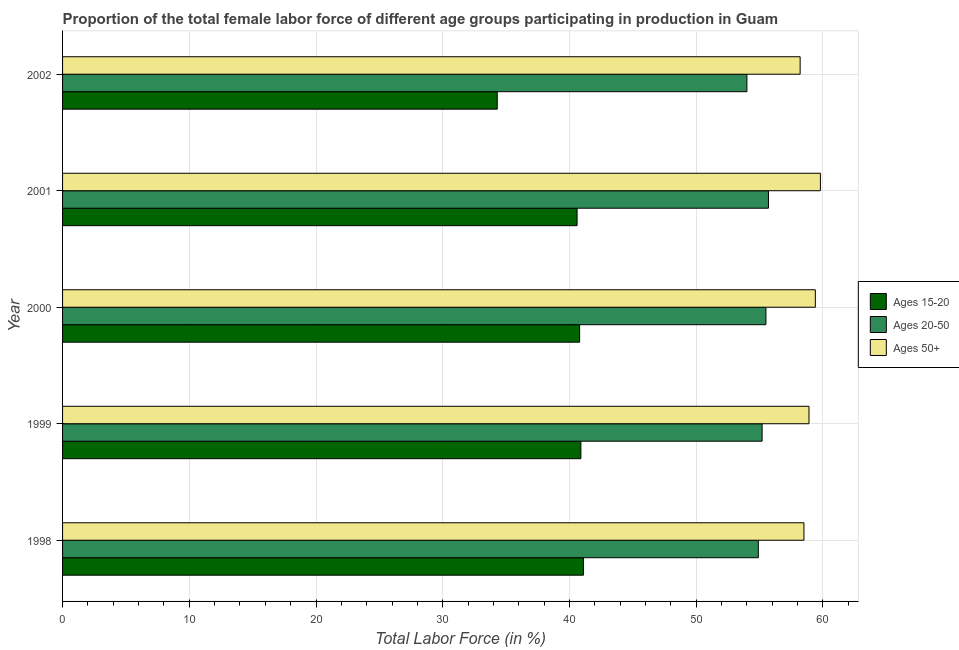How many different coloured bars are there?
Give a very brief answer. 3. Are the number of bars per tick equal to the number of legend labels?
Your answer should be compact. Yes. How many bars are there on the 3rd tick from the bottom?
Give a very brief answer. 3. What is the label of the 3rd group of bars from the top?
Offer a very short reply. 2000. In how many cases, is the number of bars for a given year not equal to the number of legend labels?
Offer a very short reply. 0. What is the percentage of female labor force above age 50 in 1998?
Provide a succinct answer. 58.5. Across all years, what is the maximum percentage of female labor force within the age group 15-20?
Keep it short and to the point. 41.1. In which year was the percentage of female labor force within the age group 20-50 maximum?
Give a very brief answer. 2001. What is the total percentage of female labor force within the age group 15-20 in the graph?
Your answer should be very brief. 197.7. What is the difference between the percentage of female labor force above age 50 in 2001 and that in 2002?
Offer a very short reply. 1.6. What is the difference between the percentage of female labor force within the age group 15-20 in 1998 and the percentage of female labor force above age 50 in 1999?
Keep it short and to the point. -17.8. What is the average percentage of female labor force within the age group 20-50 per year?
Offer a very short reply. 55.06. In how many years, is the percentage of female labor force within the age group 20-50 greater than 18 %?
Your answer should be very brief. 5. What is the ratio of the percentage of female labor force above age 50 in 1999 to that in 2002?
Ensure brevity in your answer.  1.01. Is the difference between the percentage of female labor force within the age group 20-50 in 1998 and 1999 greater than the difference between the percentage of female labor force within the age group 15-20 in 1998 and 1999?
Make the answer very short. No. What does the 3rd bar from the top in 2002 represents?
Offer a terse response. Ages 15-20. What does the 3rd bar from the bottom in 1999 represents?
Keep it short and to the point. Ages 50+. How many bars are there?
Provide a succinct answer. 15. Are all the bars in the graph horizontal?
Provide a short and direct response. Yes. How many years are there in the graph?
Provide a succinct answer. 5. Are the values on the major ticks of X-axis written in scientific E-notation?
Your response must be concise. No. What is the title of the graph?
Provide a short and direct response. Proportion of the total female labor force of different age groups participating in production in Guam. What is the Total Labor Force (in %) in Ages 15-20 in 1998?
Give a very brief answer. 41.1. What is the Total Labor Force (in %) of Ages 20-50 in 1998?
Your answer should be compact. 54.9. What is the Total Labor Force (in %) in Ages 50+ in 1998?
Provide a short and direct response. 58.5. What is the Total Labor Force (in %) of Ages 15-20 in 1999?
Provide a short and direct response. 40.9. What is the Total Labor Force (in %) in Ages 20-50 in 1999?
Make the answer very short. 55.2. What is the Total Labor Force (in %) of Ages 50+ in 1999?
Keep it short and to the point. 58.9. What is the Total Labor Force (in %) in Ages 15-20 in 2000?
Provide a short and direct response. 40.8. What is the Total Labor Force (in %) in Ages 20-50 in 2000?
Ensure brevity in your answer.  55.5. What is the Total Labor Force (in %) of Ages 50+ in 2000?
Give a very brief answer. 59.4. What is the Total Labor Force (in %) of Ages 15-20 in 2001?
Provide a succinct answer. 40.6. What is the Total Labor Force (in %) of Ages 20-50 in 2001?
Your response must be concise. 55.7. What is the Total Labor Force (in %) in Ages 50+ in 2001?
Make the answer very short. 59.8. What is the Total Labor Force (in %) in Ages 15-20 in 2002?
Offer a terse response. 34.3. What is the Total Labor Force (in %) of Ages 20-50 in 2002?
Provide a short and direct response. 54. What is the Total Labor Force (in %) of Ages 50+ in 2002?
Ensure brevity in your answer.  58.2. Across all years, what is the maximum Total Labor Force (in %) of Ages 15-20?
Give a very brief answer. 41.1. Across all years, what is the maximum Total Labor Force (in %) in Ages 20-50?
Offer a terse response. 55.7. Across all years, what is the maximum Total Labor Force (in %) in Ages 50+?
Make the answer very short. 59.8. Across all years, what is the minimum Total Labor Force (in %) of Ages 15-20?
Your response must be concise. 34.3. Across all years, what is the minimum Total Labor Force (in %) in Ages 50+?
Your answer should be compact. 58.2. What is the total Total Labor Force (in %) in Ages 15-20 in the graph?
Ensure brevity in your answer.  197.7. What is the total Total Labor Force (in %) of Ages 20-50 in the graph?
Offer a terse response. 275.3. What is the total Total Labor Force (in %) of Ages 50+ in the graph?
Your answer should be compact. 294.8. What is the difference between the Total Labor Force (in %) in Ages 15-20 in 1998 and that in 1999?
Give a very brief answer. 0.2. What is the difference between the Total Labor Force (in %) in Ages 20-50 in 1998 and that in 1999?
Make the answer very short. -0.3. What is the difference between the Total Labor Force (in %) of Ages 15-20 in 1998 and that in 2002?
Make the answer very short. 6.8. What is the difference between the Total Labor Force (in %) of Ages 50+ in 1998 and that in 2002?
Your answer should be compact. 0.3. What is the difference between the Total Labor Force (in %) in Ages 15-20 in 1999 and that in 2000?
Offer a very short reply. 0.1. What is the difference between the Total Labor Force (in %) of Ages 50+ in 1999 and that in 2000?
Offer a very short reply. -0.5. What is the difference between the Total Labor Force (in %) in Ages 15-20 in 1999 and that in 2001?
Give a very brief answer. 0.3. What is the difference between the Total Labor Force (in %) of Ages 20-50 in 1999 and that in 2001?
Make the answer very short. -0.5. What is the difference between the Total Labor Force (in %) of Ages 15-20 in 1999 and that in 2002?
Offer a very short reply. 6.6. What is the difference between the Total Labor Force (in %) of Ages 20-50 in 1999 and that in 2002?
Your answer should be very brief. 1.2. What is the difference between the Total Labor Force (in %) in Ages 15-20 in 2000 and that in 2001?
Keep it short and to the point. 0.2. What is the difference between the Total Labor Force (in %) in Ages 15-20 in 2001 and that in 2002?
Provide a short and direct response. 6.3. What is the difference between the Total Labor Force (in %) of Ages 50+ in 2001 and that in 2002?
Your answer should be very brief. 1.6. What is the difference between the Total Labor Force (in %) in Ages 15-20 in 1998 and the Total Labor Force (in %) in Ages 20-50 in 1999?
Provide a succinct answer. -14.1. What is the difference between the Total Labor Force (in %) in Ages 15-20 in 1998 and the Total Labor Force (in %) in Ages 50+ in 1999?
Your answer should be compact. -17.8. What is the difference between the Total Labor Force (in %) of Ages 15-20 in 1998 and the Total Labor Force (in %) of Ages 20-50 in 2000?
Offer a terse response. -14.4. What is the difference between the Total Labor Force (in %) in Ages 15-20 in 1998 and the Total Labor Force (in %) in Ages 50+ in 2000?
Offer a very short reply. -18.3. What is the difference between the Total Labor Force (in %) of Ages 20-50 in 1998 and the Total Labor Force (in %) of Ages 50+ in 2000?
Provide a short and direct response. -4.5. What is the difference between the Total Labor Force (in %) of Ages 15-20 in 1998 and the Total Labor Force (in %) of Ages 20-50 in 2001?
Your response must be concise. -14.6. What is the difference between the Total Labor Force (in %) in Ages 15-20 in 1998 and the Total Labor Force (in %) in Ages 50+ in 2001?
Offer a terse response. -18.7. What is the difference between the Total Labor Force (in %) in Ages 20-50 in 1998 and the Total Labor Force (in %) in Ages 50+ in 2001?
Your answer should be compact. -4.9. What is the difference between the Total Labor Force (in %) in Ages 15-20 in 1998 and the Total Labor Force (in %) in Ages 20-50 in 2002?
Make the answer very short. -12.9. What is the difference between the Total Labor Force (in %) of Ages 15-20 in 1998 and the Total Labor Force (in %) of Ages 50+ in 2002?
Offer a terse response. -17.1. What is the difference between the Total Labor Force (in %) in Ages 20-50 in 1998 and the Total Labor Force (in %) in Ages 50+ in 2002?
Offer a very short reply. -3.3. What is the difference between the Total Labor Force (in %) in Ages 15-20 in 1999 and the Total Labor Force (in %) in Ages 20-50 in 2000?
Keep it short and to the point. -14.6. What is the difference between the Total Labor Force (in %) in Ages 15-20 in 1999 and the Total Labor Force (in %) in Ages 50+ in 2000?
Give a very brief answer. -18.5. What is the difference between the Total Labor Force (in %) in Ages 20-50 in 1999 and the Total Labor Force (in %) in Ages 50+ in 2000?
Your answer should be compact. -4.2. What is the difference between the Total Labor Force (in %) of Ages 15-20 in 1999 and the Total Labor Force (in %) of Ages 20-50 in 2001?
Offer a terse response. -14.8. What is the difference between the Total Labor Force (in %) of Ages 15-20 in 1999 and the Total Labor Force (in %) of Ages 50+ in 2001?
Your answer should be compact. -18.9. What is the difference between the Total Labor Force (in %) of Ages 20-50 in 1999 and the Total Labor Force (in %) of Ages 50+ in 2001?
Your answer should be compact. -4.6. What is the difference between the Total Labor Force (in %) in Ages 15-20 in 1999 and the Total Labor Force (in %) in Ages 20-50 in 2002?
Your answer should be very brief. -13.1. What is the difference between the Total Labor Force (in %) of Ages 15-20 in 1999 and the Total Labor Force (in %) of Ages 50+ in 2002?
Your answer should be compact. -17.3. What is the difference between the Total Labor Force (in %) in Ages 20-50 in 1999 and the Total Labor Force (in %) in Ages 50+ in 2002?
Your answer should be compact. -3. What is the difference between the Total Labor Force (in %) of Ages 15-20 in 2000 and the Total Labor Force (in %) of Ages 20-50 in 2001?
Keep it short and to the point. -14.9. What is the difference between the Total Labor Force (in %) in Ages 15-20 in 2000 and the Total Labor Force (in %) in Ages 50+ in 2001?
Ensure brevity in your answer.  -19. What is the difference between the Total Labor Force (in %) of Ages 15-20 in 2000 and the Total Labor Force (in %) of Ages 20-50 in 2002?
Your response must be concise. -13.2. What is the difference between the Total Labor Force (in %) of Ages 15-20 in 2000 and the Total Labor Force (in %) of Ages 50+ in 2002?
Give a very brief answer. -17.4. What is the difference between the Total Labor Force (in %) of Ages 20-50 in 2000 and the Total Labor Force (in %) of Ages 50+ in 2002?
Make the answer very short. -2.7. What is the difference between the Total Labor Force (in %) of Ages 15-20 in 2001 and the Total Labor Force (in %) of Ages 50+ in 2002?
Offer a terse response. -17.6. What is the average Total Labor Force (in %) of Ages 15-20 per year?
Provide a short and direct response. 39.54. What is the average Total Labor Force (in %) of Ages 20-50 per year?
Keep it short and to the point. 55.06. What is the average Total Labor Force (in %) of Ages 50+ per year?
Offer a very short reply. 58.96. In the year 1998, what is the difference between the Total Labor Force (in %) in Ages 15-20 and Total Labor Force (in %) in Ages 50+?
Keep it short and to the point. -17.4. In the year 1998, what is the difference between the Total Labor Force (in %) of Ages 20-50 and Total Labor Force (in %) of Ages 50+?
Your answer should be very brief. -3.6. In the year 1999, what is the difference between the Total Labor Force (in %) of Ages 15-20 and Total Labor Force (in %) of Ages 20-50?
Keep it short and to the point. -14.3. In the year 2000, what is the difference between the Total Labor Force (in %) in Ages 15-20 and Total Labor Force (in %) in Ages 20-50?
Give a very brief answer. -14.7. In the year 2000, what is the difference between the Total Labor Force (in %) of Ages 15-20 and Total Labor Force (in %) of Ages 50+?
Your answer should be compact. -18.6. In the year 2001, what is the difference between the Total Labor Force (in %) in Ages 15-20 and Total Labor Force (in %) in Ages 20-50?
Ensure brevity in your answer.  -15.1. In the year 2001, what is the difference between the Total Labor Force (in %) of Ages 15-20 and Total Labor Force (in %) of Ages 50+?
Ensure brevity in your answer.  -19.2. In the year 2001, what is the difference between the Total Labor Force (in %) in Ages 20-50 and Total Labor Force (in %) in Ages 50+?
Give a very brief answer. -4.1. In the year 2002, what is the difference between the Total Labor Force (in %) in Ages 15-20 and Total Labor Force (in %) in Ages 20-50?
Offer a terse response. -19.7. In the year 2002, what is the difference between the Total Labor Force (in %) of Ages 15-20 and Total Labor Force (in %) of Ages 50+?
Your response must be concise. -23.9. In the year 2002, what is the difference between the Total Labor Force (in %) of Ages 20-50 and Total Labor Force (in %) of Ages 50+?
Your answer should be compact. -4.2. What is the ratio of the Total Labor Force (in %) of Ages 15-20 in 1998 to that in 1999?
Your answer should be compact. 1. What is the ratio of the Total Labor Force (in %) in Ages 50+ in 1998 to that in 1999?
Provide a short and direct response. 0.99. What is the ratio of the Total Labor Force (in %) of Ages 15-20 in 1998 to that in 2000?
Your answer should be compact. 1.01. What is the ratio of the Total Labor Force (in %) in Ages 20-50 in 1998 to that in 2000?
Provide a short and direct response. 0.99. What is the ratio of the Total Labor Force (in %) in Ages 15-20 in 1998 to that in 2001?
Offer a very short reply. 1.01. What is the ratio of the Total Labor Force (in %) of Ages 20-50 in 1998 to that in 2001?
Your response must be concise. 0.99. What is the ratio of the Total Labor Force (in %) of Ages 50+ in 1998 to that in 2001?
Ensure brevity in your answer.  0.98. What is the ratio of the Total Labor Force (in %) in Ages 15-20 in 1998 to that in 2002?
Ensure brevity in your answer.  1.2. What is the ratio of the Total Labor Force (in %) of Ages 20-50 in 1998 to that in 2002?
Your answer should be very brief. 1.02. What is the ratio of the Total Labor Force (in %) in Ages 50+ in 1998 to that in 2002?
Your response must be concise. 1.01. What is the ratio of the Total Labor Force (in %) of Ages 20-50 in 1999 to that in 2000?
Your answer should be very brief. 0.99. What is the ratio of the Total Labor Force (in %) in Ages 50+ in 1999 to that in 2000?
Provide a succinct answer. 0.99. What is the ratio of the Total Labor Force (in %) of Ages 15-20 in 1999 to that in 2001?
Your answer should be very brief. 1.01. What is the ratio of the Total Labor Force (in %) of Ages 20-50 in 1999 to that in 2001?
Your answer should be very brief. 0.99. What is the ratio of the Total Labor Force (in %) of Ages 50+ in 1999 to that in 2001?
Your answer should be very brief. 0.98. What is the ratio of the Total Labor Force (in %) in Ages 15-20 in 1999 to that in 2002?
Make the answer very short. 1.19. What is the ratio of the Total Labor Force (in %) in Ages 20-50 in 1999 to that in 2002?
Your answer should be very brief. 1.02. What is the ratio of the Total Labor Force (in %) in Ages 50+ in 1999 to that in 2002?
Offer a terse response. 1.01. What is the ratio of the Total Labor Force (in %) of Ages 15-20 in 2000 to that in 2001?
Keep it short and to the point. 1. What is the ratio of the Total Labor Force (in %) in Ages 20-50 in 2000 to that in 2001?
Keep it short and to the point. 1. What is the ratio of the Total Labor Force (in %) of Ages 15-20 in 2000 to that in 2002?
Provide a succinct answer. 1.19. What is the ratio of the Total Labor Force (in %) in Ages 20-50 in 2000 to that in 2002?
Provide a succinct answer. 1.03. What is the ratio of the Total Labor Force (in %) of Ages 50+ in 2000 to that in 2002?
Offer a terse response. 1.02. What is the ratio of the Total Labor Force (in %) of Ages 15-20 in 2001 to that in 2002?
Provide a succinct answer. 1.18. What is the ratio of the Total Labor Force (in %) in Ages 20-50 in 2001 to that in 2002?
Provide a succinct answer. 1.03. What is the ratio of the Total Labor Force (in %) of Ages 50+ in 2001 to that in 2002?
Ensure brevity in your answer.  1.03. What is the difference between the highest and the second highest Total Labor Force (in %) in Ages 20-50?
Offer a terse response. 0.2. What is the difference between the highest and the second highest Total Labor Force (in %) in Ages 50+?
Your answer should be compact. 0.4. What is the difference between the highest and the lowest Total Labor Force (in %) in Ages 20-50?
Keep it short and to the point. 1.7. What is the difference between the highest and the lowest Total Labor Force (in %) of Ages 50+?
Provide a succinct answer. 1.6. 